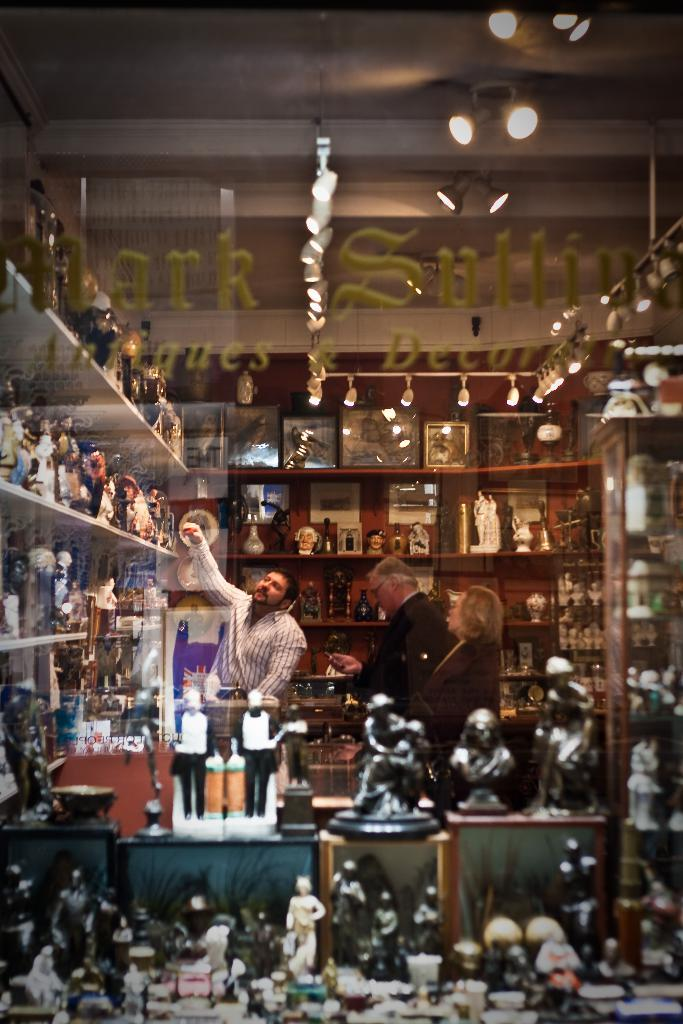How many people are in the image? There are three persons standing in the image. What can be seen around the persons? There are toys placed on shelves around the persons. What is located above the persons in the image? There are lights above the persons in the image. What type of baseball equipment can be seen in the image? There is no baseball equipment present in the image. Where is the plant located in the image? There is no plant present in the image. 